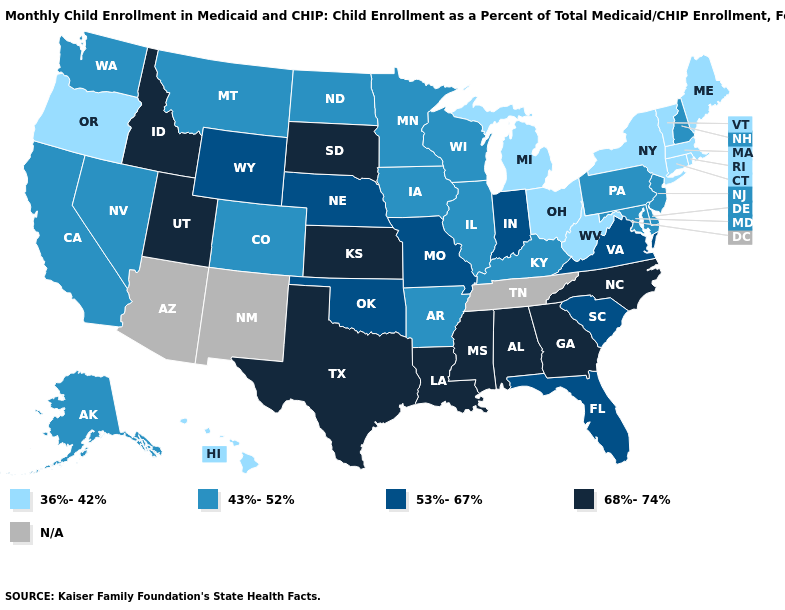What is the value of Hawaii?
Answer briefly. 36%-42%. Among the states that border Wyoming , which have the highest value?
Give a very brief answer. Idaho, South Dakota, Utah. What is the lowest value in the South?
Be succinct. 36%-42%. Does Maine have the lowest value in the Northeast?
Short answer required. Yes. Name the states that have a value in the range 68%-74%?
Quick response, please. Alabama, Georgia, Idaho, Kansas, Louisiana, Mississippi, North Carolina, South Dakota, Texas, Utah. What is the value of New York?
Quick response, please. 36%-42%. Among the states that border Montana , which have the highest value?
Quick response, please. Idaho, South Dakota. Among the states that border Ohio , which have the highest value?
Answer briefly. Indiana. Among the states that border Washington , does Oregon have the highest value?
Give a very brief answer. No. Which states have the lowest value in the South?
Concise answer only. West Virginia. What is the value of Maine?
Write a very short answer. 36%-42%. Name the states that have a value in the range N/A?
Be succinct. Arizona, New Mexico, Tennessee. Name the states that have a value in the range 36%-42%?
Short answer required. Connecticut, Hawaii, Maine, Massachusetts, Michigan, New York, Ohio, Oregon, Rhode Island, Vermont, West Virginia. Which states hav the highest value in the MidWest?
Keep it brief. Kansas, South Dakota. 